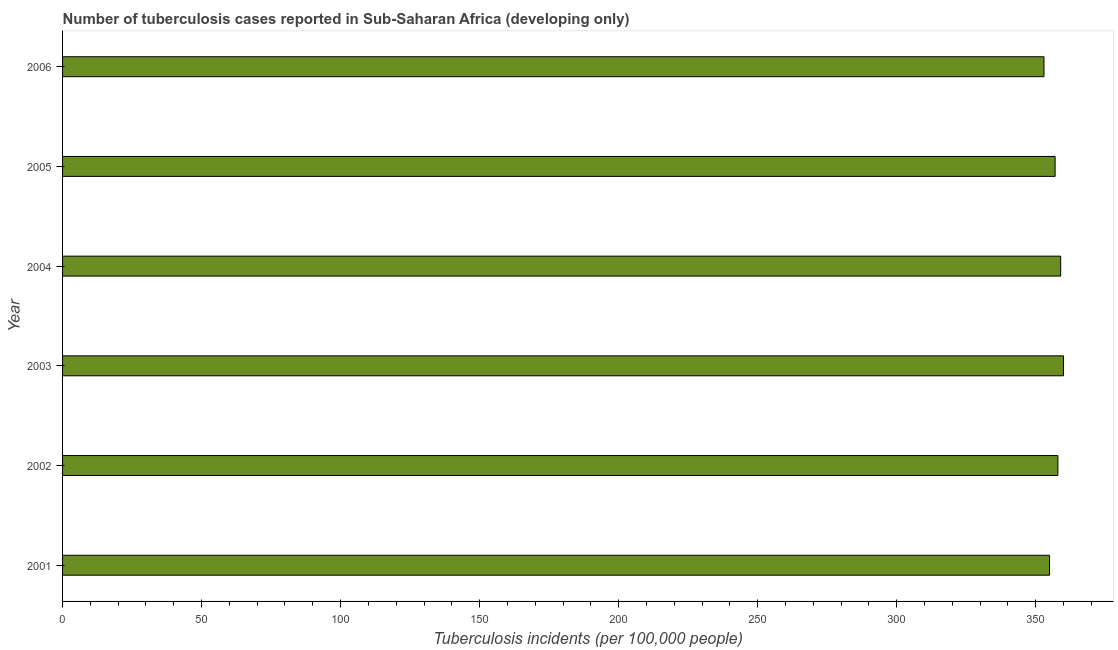What is the title of the graph?
Make the answer very short. Number of tuberculosis cases reported in Sub-Saharan Africa (developing only). What is the label or title of the X-axis?
Provide a succinct answer. Tuberculosis incidents (per 100,0 people). What is the label or title of the Y-axis?
Ensure brevity in your answer.  Year. What is the number of tuberculosis incidents in 2002?
Your answer should be very brief. 358. Across all years, what is the maximum number of tuberculosis incidents?
Provide a succinct answer. 360. Across all years, what is the minimum number of tuberculosis incidents?
Provide a short and direct response. 353. What is the sum of the number of tuberculosis incidents?
Offer a very short reply. 2142. What is the difference between the number of tuberculosis incidents in 2001 and 2002?
Your answer should be very brief. -3. What is the average number of tuberculosis incidents per year?
Provide a succinct answer. 357. What is the median number of tuberculosis incidents?
Keep it short and to the point. 357.5. Is the difference between the number of tuberculosis incidents in 2004 and 2006 greater than the difference between any two years?
Offer a very short reply. No. Is the sum of the number of tuberculosis incidents in 2003 and 2004 greater than the maximum number of tuberculosis incidents across all years?
Your answer should be compact. Yes. How many bars are there?
Give a very brief answer. 6. Are all the bars in the graph horizontal?
Your answer should be very brief. Yes. Are the values on the major ticks of X-axis written in scientific E-notation?
Your answer should be compact. No. What is the Tuberculosis incidents (per 100,000 people) in 2001?
Ensure brevity in your answer.  355. What is the Tuberculosis incidents (per 100,000 people) in 2002?
Give a very brief answer. 358. What is the Tuberculosis incidents (per 100,000 people) of 2003?
Your answer should be compact. 360. What is the Tuberculosis incidents (per 100,000 people) of 2004?
Provide a succinct answer. 359. What is the Tuberculosis incidents (per 100,000 people) in 2005?
Ensure brevity in your answer.  357. What is the Tuberculosis incidents (per 100,000 people) of 2006?
Your response must be concise. 353. What is the difference between the Tuberculosis incidents (per 100,000 people) in 2002 and 2006?
Your answer should be compact. 5. What is the difference between the Tuberculosis incidents (per 100,000 people) in 2004 and 2005?
Provide a short and direct response. 2. What is the difference between the Tuberculosis incidents (per 100,000 people) in 2004 and 2006?
Offer a terse response. 6. What is the ratio of the Tuberculosis incidents (per 100,000 people) in 2001 to that in 2003?
Provide a succinct answer. 0.99. What is the ratio of the Tuberculosis incidents (per 100,000 people) in 2001 to that in 2006?
Keep it short and to the point. 1.01. What is the ratio of the Tuberculosis incidents (per 100,000 people) in 2002 to that in 2004?
Ensure brevity in your answer.  1. What is the ratio of the Tuberculosis incidents (per 100,000 people) in 2003 to that in 2006?
Your response must be concise. 1.02. What is the ratio of the Tuberculosis incidents (per 100,000 people) in 2004 to that in 2005?
Offer a very short reply. 1.01. What is the ratio of the Tuberculosis incidents (per 100,000 people) in 2005 to that in 2006?
Your answer should be very brief. 1.01. 